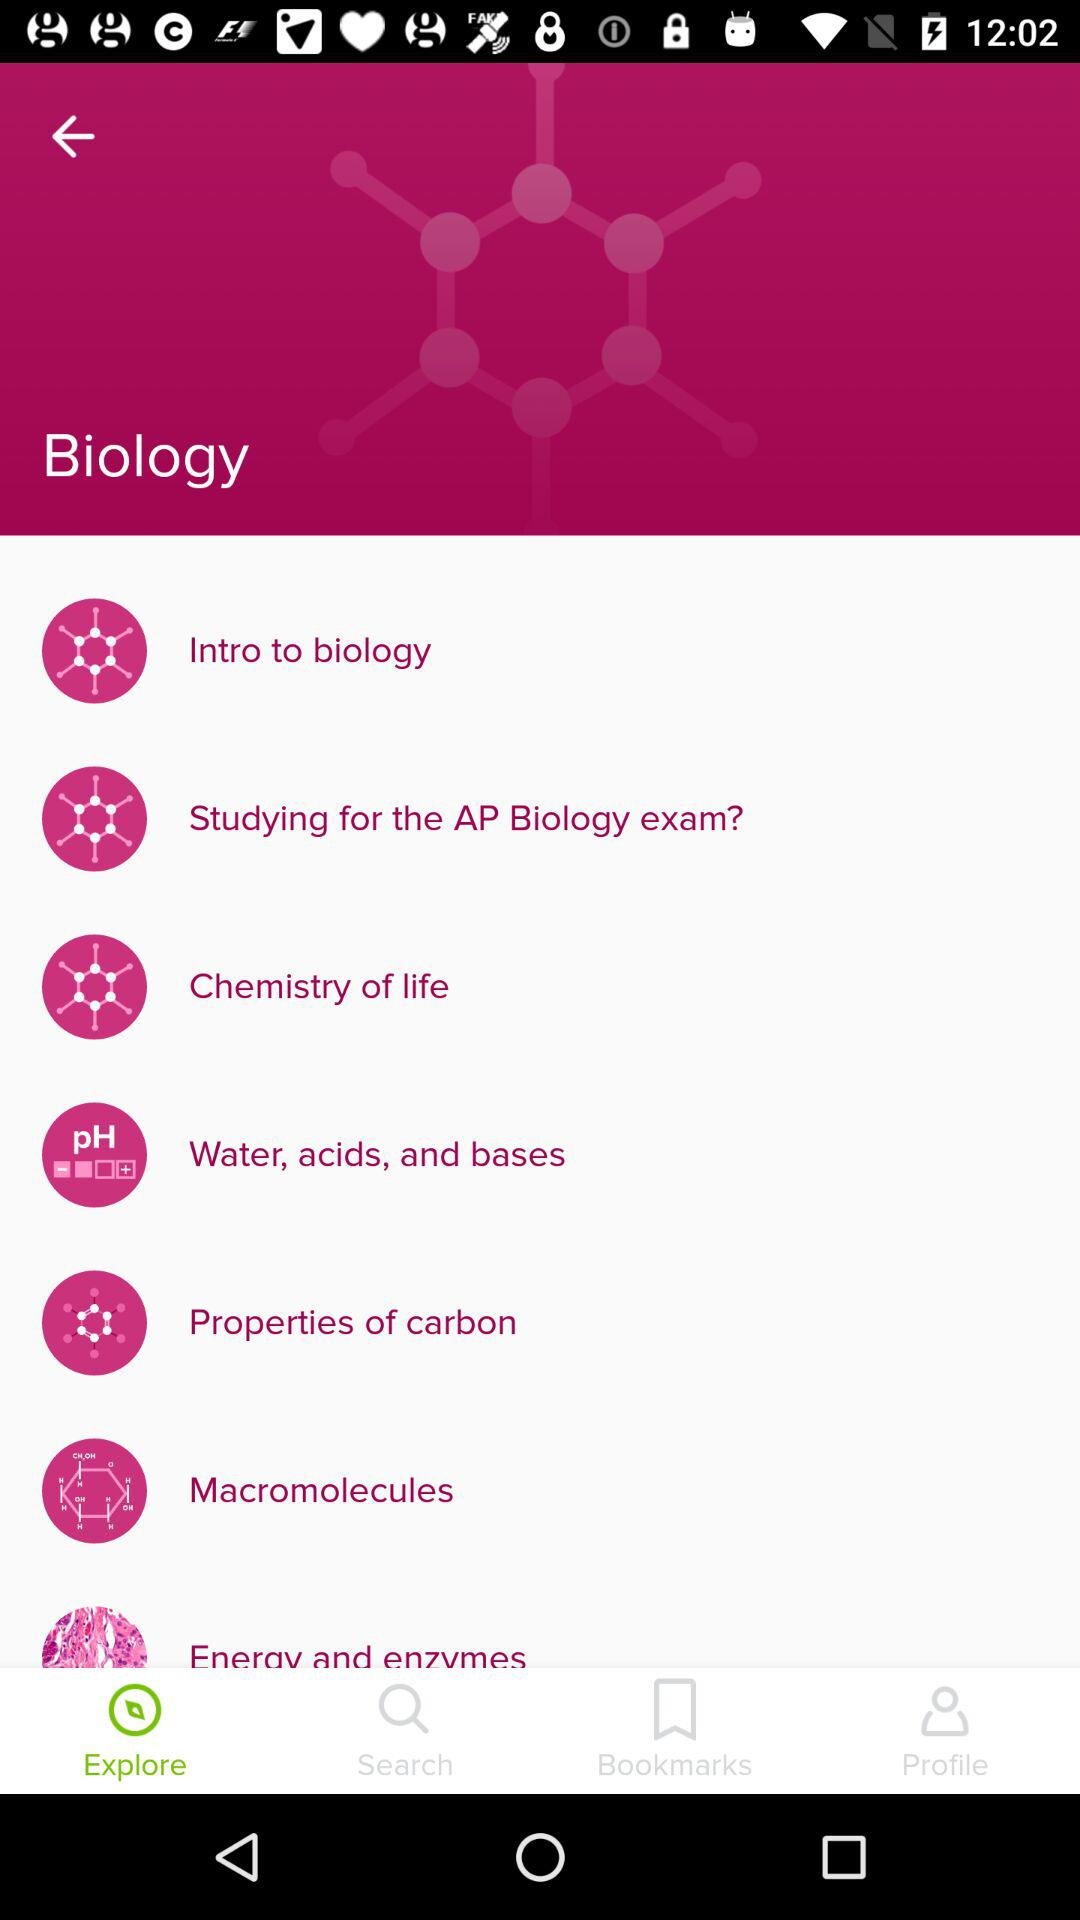What are the available topics? The available topics are "Intro to biology", "Studying for the AP Biology exam?", "Chemistry of life", "Water, acids, and bases", "Properties of carbon", "Macromolecules" and "Energy and enzymes". 